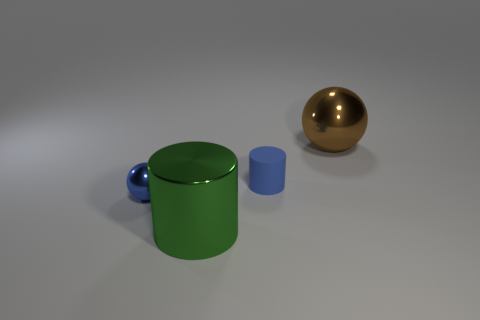What is the material of the other thing that is the same color as the matte object?
Your answer should be very brief. Metal. Are there any other things that are made of the same material as the small cylinder?
Your answer should be compact. No. What number of purple objects are either tiny matte things or large objects?
Your answer should be compact. 0. What color is the shiny object that is on the right side of the small metallic object and to the left of the large brown metallic ball?
Provide a succinct answer. Green. How many small objects are either brown things or green objects?
Your answer should be very brief. 0. There is a brown metal thing that is the same shape as the tiny blue metal thing; what is its size?
Your response must be concise. Large. The large brown metal thing is what shape?
Your answer should be compact. Sphere. Do the big green thing and the ball that is in front of the brown object have the same material?
Keep it short and to the point. Yes. What number of matte things are either brown objects or small cylinders?
Keep it short and to the point. 1. What size is the object that is right of the blue rubber cylinder?
Provide a short and direct response. Large. 